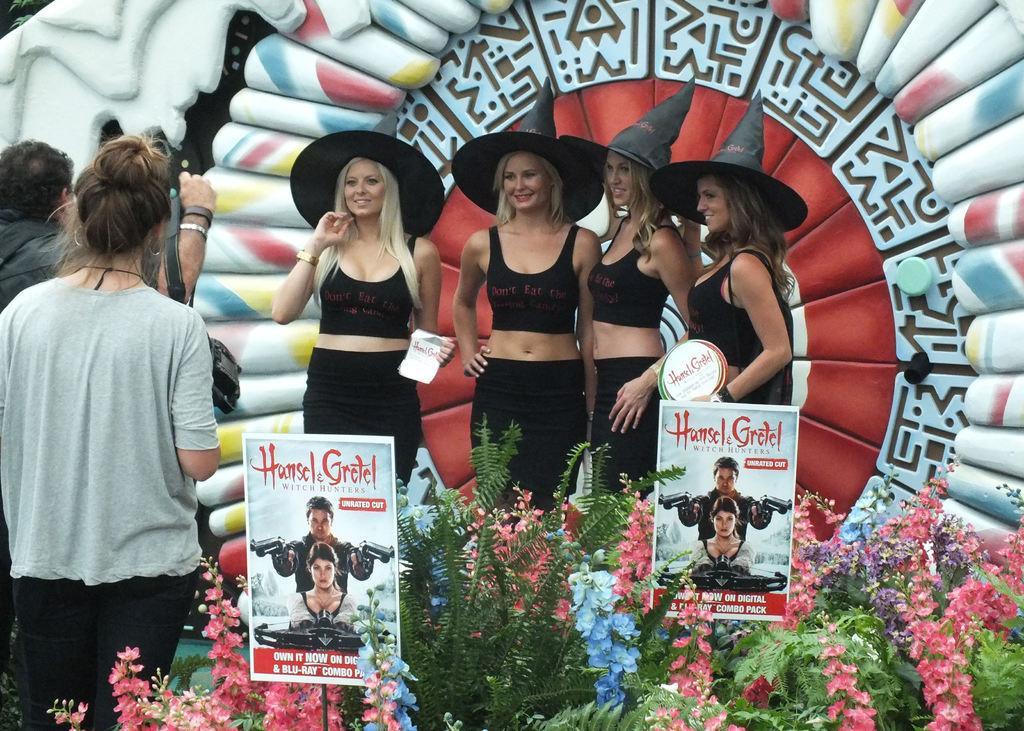How would you summarize this image in a sentence or two? In the middle of the picture, we see four women in black dresses and black hats are posing for the photo. All of them are smiling. In front of them, we see plants and two boards with posters pasted on it. On the left side, the woman in grey T-shirt is standing. In front of her, the man in black jacket is clicking photos on the camera. 